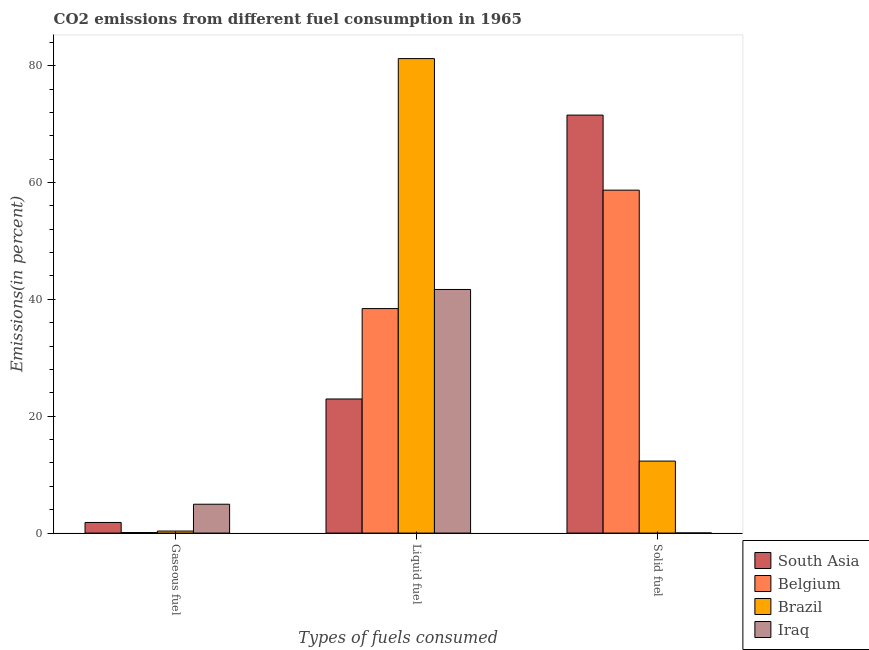How many different coloured bars are there?
Your answer should be very brief. 4. How many groups of bars are there?
Your response must be concise. 3. Are the number of bars on each tick of the X-axis equal?
Your response must be concise. Yes. How many bars are there on the 2nd tick from the left?
Your answer should be compact. 4. How many bars are there on the 1st tick from the right?
Provide a short and direct response. 4. What is the label of the 2nd group of bars from the left?
Your answer should be very brief. Liquid fuel. What is the percentage of liquid fuel emission in South Asia?
Offer a terse response. 22.95. Across all countries, what is the maximum percentage of gaseous fuel emission?
Offer a terse response. 4.94. Across all countries, what is the minimum percentage of solid fuel emission?
Your response must be concise. 0.02. What is the total percentage of liquid fuel emission in the graph?
Provide a short and direct response. 184.28. What is the difference between the percentage of liquid fuel emission in Brazil and that in South Asia?
Your response must be concise. 58.26. What is the difference between the percentage of liquid fuel emission in Brazil and the percentage of gaseous fuel emission in Belgium?
Keep it short and to the point. 81.12. What is the average percentage of solid fuel emission per country?
Give a very brief answer. 35.64. What is the difference between the percentage of liquid fuel emission and percentage of solid fuel emission in Belgium?
Provide a succinct answer. -20.27. What is the ratio of the percentage of liquid fuel emission in Belgium to that in South Asia?
Your answer should be very brief. 1.67. What is the difference between the highest and the second highest percentage of solid fuel emission?
Ensure brevity in your answer.  12.84. What is the difference between the highest and the lowest percentage of liquid fuel emission?
Provide a short and direct response. 58.26. Is the sum of the percentage of gaseous fuel emission in Brazil and Belgium greater than the maximum percentage of liquid fuel emission across all countries?
Provide a short and direct response. No. What does the 4th bar from the left in Solid fuel represents?
Your response must be concise. Iraq. Are all the bars in the graph horizontal?
Give a very brief answer. No. Are the values on the major ticks of Y-axis written in scientific E-notation?
Your response must be concise. No. Does the graph contain grids?
Keep it short and to the point. No. What is the title of the graph?
Offer a very short reply. CO2 emissions from different fuel consumption in 1965. Does "St. Lucia" appear as one of the legend labels in the graph?
Your answer should be very brief. No. What is the label or title of the X-axis?
Ensure brevity in your answer.  Types of fuels consumed. What is the label or title of the Y-axis?
Your answer should be compact. Emissions(in percent). What is the Emissions(in percent) of South Asia in Gaseous fuel?
Offer a terse response. 1.82. What is the Emissions(in percent) in Belgium in Gaseous fuel?
Your answer should be compact. 0.09. What is the Emissions(in percent) in Brazil in Gaseous fuel?
Your answer should be very brief. 0.34. What is the Emissions(in percent) in Iraq in Gaseous fuel?
Provide a short and direct response. 4.94. What is the Emissions(in percent) in South Asia in Liquid fuel?
Your answer should be compact. 22.95. What is the Emissions(in percent) in Belgium in Liquid fuel?
Your answer should be compact. 38.42. What is the Emissions(in percent) in Brazil in Liquid fuel?
Your answer should be very brief. 81.21. What is the Emissions(in percent) of Iraq in Liquid fuel?
Give a very brief answer. 41.69. What is the Emissions(in percent) in South Asia in Solid fuel?
Make the answer very short. 71.54. What is the Emissions(in percent) of Belgium in Solid fuel?
Provide a short and direct response. 58.69. What is the Emissions(in percent) in Brazil in Solid fuel?
Your answer should be very brief. 12.32. What is the Emissions(in percent) of Iraq in Solid fuel?
Provide a succinct answer. 0.02. Across all Types of fuels consumed, what is the maximum Emissions(in percent) in South Asia?
Provide a short and direct response. 71.54. Across all Types of fuels consumed, what is the maximum Emissions(in percent) of Belgium?
Offer a terse response. 58.69. Across all Types of fuels consumed, what is the maximum Emissions(in percent) of Brazil?
Keep it short and to the point. 81.21. Across all Types of fuels consumed, what is the maximum Emissions(in percent) in Iraq?
Keep it short and to the point. 41.69. Across all Types of fuels consumed, what is the minimum Emissions(in percent) of South Asia?
Your answer should be compact. 1.82. Across all Types of fuels consumed, what is the minimum Emissions(in percent) of Belgium?
Your answer should be compact. 0.09. Across all Types of fuels consumed, what is the minimum Emissions(in percent) in Brazil?
Provide a short and direct response. 0.34. Across all Types of fuels consumed, what is the minimum Emissions(in percent) in Iraq?
Offer a terse response. 0.02. What is the total Emissions(in percent) in South Asia in the graph?
Offer a terse response. 96.31. What is the total Emissions(in percent) in Belgium in the graph?
Provide a short and direct response. 97.21. What is the total Emissions(in percent) of Brazil in the graph?
Your answer should be compact. 93.88. What is the total Emissions(in percent) of Iraq in the graph?
Ensure brevity in your answer.  46.65. What is the difference between the Emissions(in percent) in South Asia in Gaseous fuel and that in Liquid fuel?
Offer a terse response. -21.14. What is the difference between the Emissions(in percent) in Belgium in Gaseous fuel and that in Liquid fuel?
Provide a short and direct response. -38.33. What is the difference between the Emissions(in percent) in Brazil in Gaseous fuel and that in Liquid fuel?
Offer a terse response. -80.86. What is the difference between the Emissions(in percent) in Iraq in Gaseous fuel and that in Liquid fuel?
Your answer should be compact. -36.76. What is the difference between the Emissions(in percent) of South Asia in Gaseous fuel and that in Solid fuel?
Keep it short and to the point. -69.72. What is the difference between the Emissions(in percent) of Belgium in Gaseous fuel and that in Solid fuel?
Your response must be concise. -58.6. What is the difference between the Emissions(in percent) of Brazil in Gaseous fuel and that in Solid fuel?
Your answer should be very brief. -11.98. What is the difference between the Emissions(in percent) in Iraq in Gaseous fuel and that in Solid fuel?
Keep it short and to the point. 4.92. What is the difference between the Emissions(in percent) in South Asia in Liquid fuel and that in Solid fuel?
Offer a very short reply. -48.59. What is the difference between the Emissions(in percent) of Belgium in Liquid fuel and that in Solid fuel?
Your response must be concise. -20.27. What is the difference between the Emissions(in percent) of Brazil in Liquid fuel and that in Solid fuel?
Provide a short and direct response. 68.89. What is the difference between the Emissions(in percent) of Iraq in Liquid fuel and that in Solid fuel?
Make the answer very short. 41.67. What is the difference between the Emissions(in percent) of South Asia in Gaseous fuel and the Emissions(in percent) of Belgium in Liquid fuel?
Offer a terse response. -36.61. What is the difference between the Emissions(in percent) in South Asia in Gaseous fuel and the Emissions(in percent) in Brazil in Liquid fuel?
Ensure brevity in your answer.  -79.39. What is the difference between the Emissions(in percent) of South Asia in Gaseous fuel and the Emissions(in percent) of Iraq in Liquid fuel?
Keep it short and to the point. -39.88. What is the difference between the Emissions(in percent) of Belgium in Gaseous fuel and the Emissions(in percent) of Brazil in Liquid fuel?
Make the answer very short. -81.12. What is the difference between the Emissions(in percent) in Belgium in Gaseous fuel and the Emissions(in percent) in Iraq in Liquid fuel?
Make the answer very short. -41.6. What is the difference between the Emissions(in percent) of Brazil in Gaseous fuel and the Emissions(in percent) of Iraq in Liquid fuel?
Your response must be concise. -41.35. What is the difference between the Emissions(in percent) in South Asia in Gaseous fuel and the Emissions(in percent) in Belgium in Solid fuel?
Your answer should be compact. -56.88. What is the difference between the Emissions(in percent) in South Asia in Gaseous fuel and the Emissions(in percent) in Brazil in Solid fuel?
Offer a terse response. -10.51. What is the difference between the Emissions(in percent) of South Asia in Gaseous fuel and the Emissions(in percent) of Iraq in Solid fuel?
Offer a very short reply. 1.8. What is the difference between the Emissions(in percent) in Belgium in Gaseous fuel and the Emissions(in percent) in Brazil in Solid fuel?
Make the answer very short. -12.23. What is the difference between the Emissions(in percent) of Belgium in Gaseous fuel and the Emissions(in percent) of Iraq in Solid fuel?
Offer a terse response. 0.07. What is the difference between the Emissions(in percent) of Brazil in Gaseous fuel and the Emissions(in percent) of Iraq in Solid fuel?
Your answer should be very brief. 0.33. What is the difference between the Emissions(in percent) of South Asia in Liquid fuel and the Emissions(in percent) of Belgium in Solid fuel?
Provide a succinct answer. -35.74. What is the difference between the Emissions(in percent) in South Asia in Liquid fuel and the Emissions(in percent) in Brazil in Solid fuel?
Your answer should be compact. 10.63. What is the difference between the Emissions(in percent) of South Asia in Liquid fuel and the Emissions(in percent) of Iraq in Solid fuel?
Provide a succinct answer. 22.93. What is the difference between the Emissions(in percent) of Belgium in Liquid fuel and the Emissions(in percent) of Brazil in Solid fuel?
Keep it short and to the point. 26.1. What is the difference between the Emissions(in percent) in Belgium in Liquid fuel and the Emissions(in percent) in Iraq in Solid fuel?
Your answer should be compact. 38.4. What is the difference between the Emissions(in percent) of Brazil in Liquid fuel and the Emissions(in percent) of Iraq in Solid fuel?
Your answer should be very brief. 81.19. What is the average Emissions(in percent) of South Asia per Types of fuels consumed?
Ensure brevity in your answer.  32.1. What is the average Emissions(in percent) of Belgium per Types of fuels consumed?
Keep it short and to the point. 32.4. What is the average Emissions(in percent) of Brazil per Types of fuels consumed?
Provide a short and direct response. 31.29. What is the average Emissions(in percent) of Iraq per Types of fuels consumed?
Offer a terse response. 15.55. What is the difference between the Emissions(in percent) in South Asia and Emissions(in percent) in Belgium in Gaseous fuel?
Provide a succinct answer. 1.73. What is the difference between the Emissions(in percent) of South Asia and Emissions(in percent) of Brazil in Gaseous fuel?
Provide a short and direct response. 1.47. What is the difference between the Emissions(in percent) of South Asia and Emissions(in percent) of Iraq in Gaseous fuel?
Keep it short and to the point. -3.12. What is the difference between the Emissions(in percent) in Belgium and Emissions(in percent) in Brazil in Gaseous fuel?
Keep it short and to the point. -0.25. What is the difference between the Emissions(in percent) in Belgium and Emissions(in percent) in Iraq in Gaseous fuel?
Ensure brevity in your answer.  -4.85. What is the difference between the Emissions(in percent) in Brazil and Emissions(in percent) in Iraq in Gaseous fuel?
Offer a terse response. -4.59. What is the difference between the Emissions(in percent) of South Asia and Emissions(in percent) of Belgium in Liquid fuel?
Give a very brief answer. -15.47. What is the difference between the Emissions(in percent) in South Asia and Emissions(in percent) in Brazil in Liquid fuel?
Provide a short and direct response. -58.26. What is the difference between the Emissions(in percent) in South Asia and Emissions(in percent) in Iraq in Liquid fuel?
Offer a terse response. -18.74. What is the difference between the Emissions(in percent) of Belgium and Emissions(in percent) of Brazil in Liquid fuel?
Your answer should be very brief. -42.79. What is the difference between the Emissions(in percent) of Belgium and Emissions(in percent) of Iraq in Liquid fuel?
Provide a short and direct response. -3.27. What is the difference between the Emissions(in percent) in Brazil and Emissions(in percent) in Iraq in Liquid fuel?
Ensure brevity in your answer.  39.52. What is the difference between the Emissions(in percent) in South Asia and Emissions(in percent) in Belgium in Solid fuel?
Your answer should be compact. 12.84. What is the difference between the Emissions(in percent) in South Asia and Emissions(in percent) in Brazil in Solid fuel?
Ensure brevity in your answer.  59.22. What is the difference between the Emissions(in percent) in South Asia and Emissions(in percent) in Iraq in Solid fuel?
Offer a terse response. 71.52. What is the difference between the Emissions(in percent) of Belgium and Emissions(in percent) of Brazil in Solid fuel?
Provide a short and direct response. 46.37. What is the difference between the Emissions(in percent) of Belgium and Emissions(in percent) of Iraq in Solid fuel?
Your answer should be compact. 58.68. What is the difference between the Emissions(in percent) in Brazil and Emissions(in percent) in Iraq in Solid fuel?
Offer a very short reply. 12.3. What is the ratio of the Emissions(in percent) in South Asia in Gaseous fuel to that in Liquid fuel?
Give a very brief answer. 0.08. What is the ratio of the Emissions(in percent) of Belgium in Gaseous fuel to that in Liquid fuel?
Ensure brevity in your answer.  0. What is the ratio of the Emissions(in percent) of Brazil in Gaseous fuel to that in Liquid fuel?
Provide a succinct answer. 0. What is the ratio of the Emissions(in percent) of Iraq in Gaseous fuel to that in Liquid fuel?
Your response must be concise. 0.12. What is the ratio of the Emissions(in percent) of South Asia in Gaseous fuel to that in Solid fuel?
Keep it short and to the point. 0.03. What is the ratio of the Emissions(in percent) in Belgium in Gaseous fuel to that in Solid fuel?
Provide a succinct answer. 0. What is the ratio of the Emissions(in percent) in Brazil in Gaseous fuel to that in Solid fuel?
Your answer should be very brief. 0.03. What is the ratio of the Emissions(in percent) in Iraq in Gaseous fuel to that in Solid fuel?
Ensure brevity in your answer.  260. What is the ratio of the Emissions(in percent) in South Asia in Liquid fuel to that in Solid fuel?
Your answer should be very brief. 0.32. What is the ratio of the Emissions(in percent) in Belgium in Liquid fuel to that in Solid fuel?
Provide a short and direct response. 0.65. What is the ratio of the Emissions(in percent) in Brazil in Liquid fuel to that in Solid fuel?
Keep it short and to the point. 6.59. What is the ratio of the Emissions(in percent) of Iraq in Liquid fuel to that in Solid fuel?
Make the answer very short. 2196. What is the difference between the highest and the second highest Emissions(in percent) of South Asia?
Provide a succinct answer. 48.59. What is the difference between the highest and the second highest Emissions(in percent) of Belgium?
Your response must be concise. 20.27. What is the difference between the highest and the second highest Emissions(in percent) in Brazil?
Give a very brief answer. 68.89. What is the difference between the highest and the second highest Emissions(in percent) of Iraq?
Keep it short and to the point. 36.76. What is the difference between the highest and the lowest Emissions(in percent) in South Asia?
Keep it short and to the point. 69.72. What is the difference between the highest and the lowest Emissions(in percent) in Belgium?
Provide a succinct answer. 58.6. What is the difference between the highest and the lowest Emissions(in percent) in Brazil?
Your answer should be compact. 80.86. What is the difference between the highest and the lowest Emissions(in percent) of Iraq?
Make the answer very short. 41.67. 